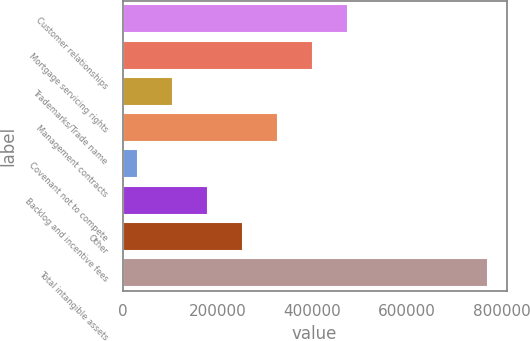Convert chart to OTSL. <chart><loc_0><loc_0><loc_500><loc_500><bar_chart><fcel>Customer relationships<fcel>Mortgage servicing rights<fcel>Trademarks/Trade name<fcel>Management contracts<fcel>Covenant not to compete<fcel>Backlog and incentive fees<fcel>Other<fcel>Total intangible assets<nl><fcel>476115<fcel>402225<fcel>106667<fcel>328335<fcel>32777<fcel>180556<fcel>254446<fcel>771673<nl></chart> 